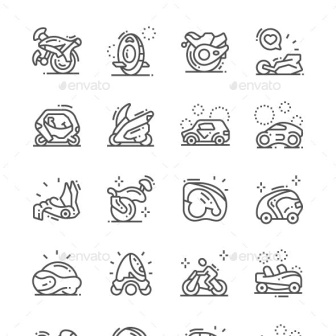Can you describe how the aesthetic style of the icons might influence our perception of these modes of transportation? The minimalist line art style of these icons contributes to a clean and modern perception of the modes of transportation depicted. This style tends to strip away any unnecessary details, focusing on the basic form and function, which can make the modes of transportation appear more sleek, efficient, and accessible. It's an artistic choice that reflects a modern, perhaps idealized, vision of mobility where design and functionality are harmonized. 